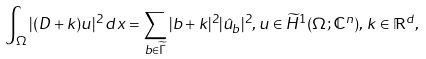Convert formula to latex. <formula><loc_0><loc_0><loc_500><loc_500>\int _ { \Omega } | ( D + k ) u | ^ { 2 } \, d x = \sum _ { b \in \widetilde { \Gamma } } | b + k | ^ { 2 } | \hat { u } _ { b } | ^ { 2 } , u \in \widetilde { H } ^ { 1 } ( \Omega ; \mathbb { C } ^ { n } ) , \, k \in \mathbb { R } ^ { d } ,</formula> 